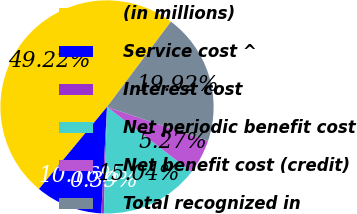Convert chart. <chart><loc_0><loc_0><loc_500><loc_500><pie_chart><fcel>(in millions)<fcel>Service cost ^<fcel>Interest cost<fcel>Net periodic benefit cost<fcel>Net benefit cost (credit)<fcel>Total recognized in<nl><fcel>49.22%<fcel>10.16%<fcel>0.39%<fcel>15.04%<fcel>5.27%<fcel>19.92%<nl></chart> 